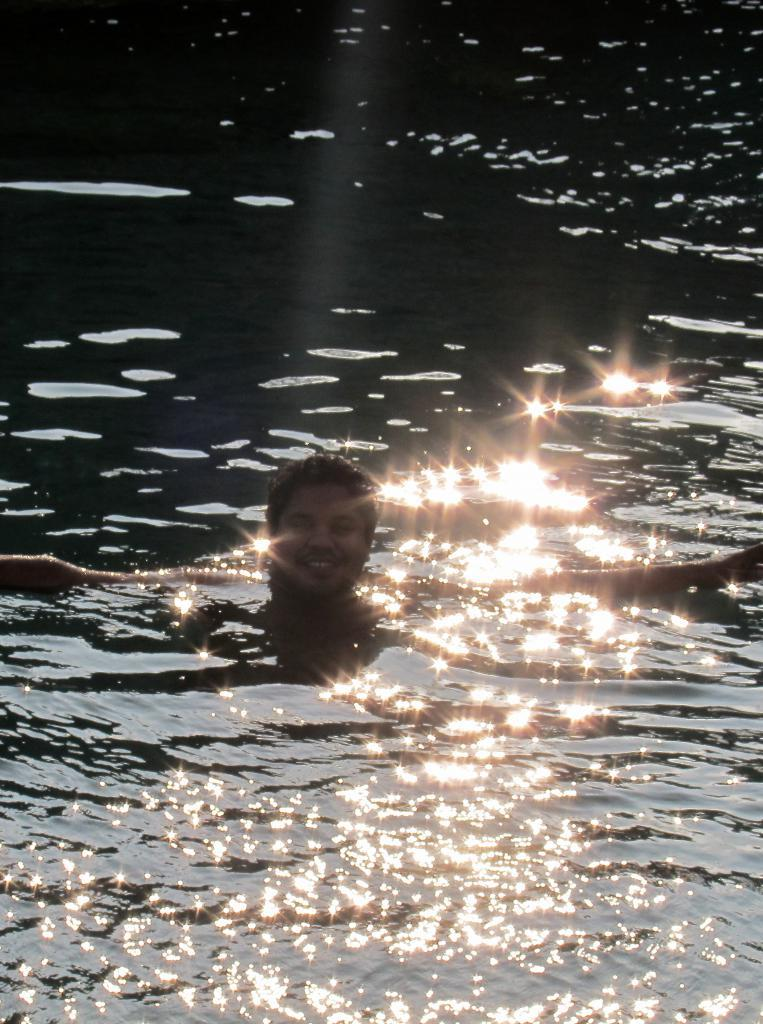What is the person in the image doing? There is a person in the water in the image. What can be observed on the surface of the water? There is light reflection on the water. How does the light reflection appear? The light reflection is shining. What type of prose is being sold at the market in the image? There is no market or prose present in the image; it features a person in the water and light reflection on the water. Can you tell me how many chess pieces are visible in the image? There are no chess pieces present in the image. 